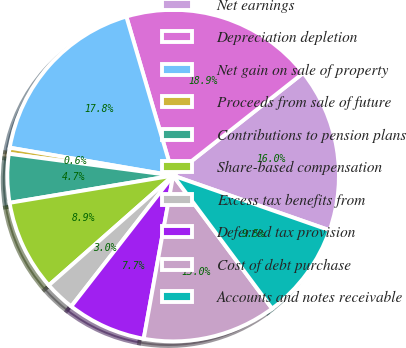<chart> <loc_0><loc_0><loc_500><loc_500><pie_chart><fcel>Net earnings<fcel>Depreciation depletion<fcel>Net gain on sale of property<fcel>Proceeds from sale of future<fcel>Contributions to pension plans<fcel>Share-based compensation<fcel>Excess tax benefits from<fcel>Deferred tax provision<fcel>Cost of debt purchase<fcel>Accounts and notes receivable<nl><fcel>15.98%<fcel>18.93%<fcel>17.75%<fcel>0.59%<fcel>4.73%<fcel>8.88%<fcel>2.96%<fcel>7.69%<fcel>13.02%<fcel>9.47%<nl></chart> 